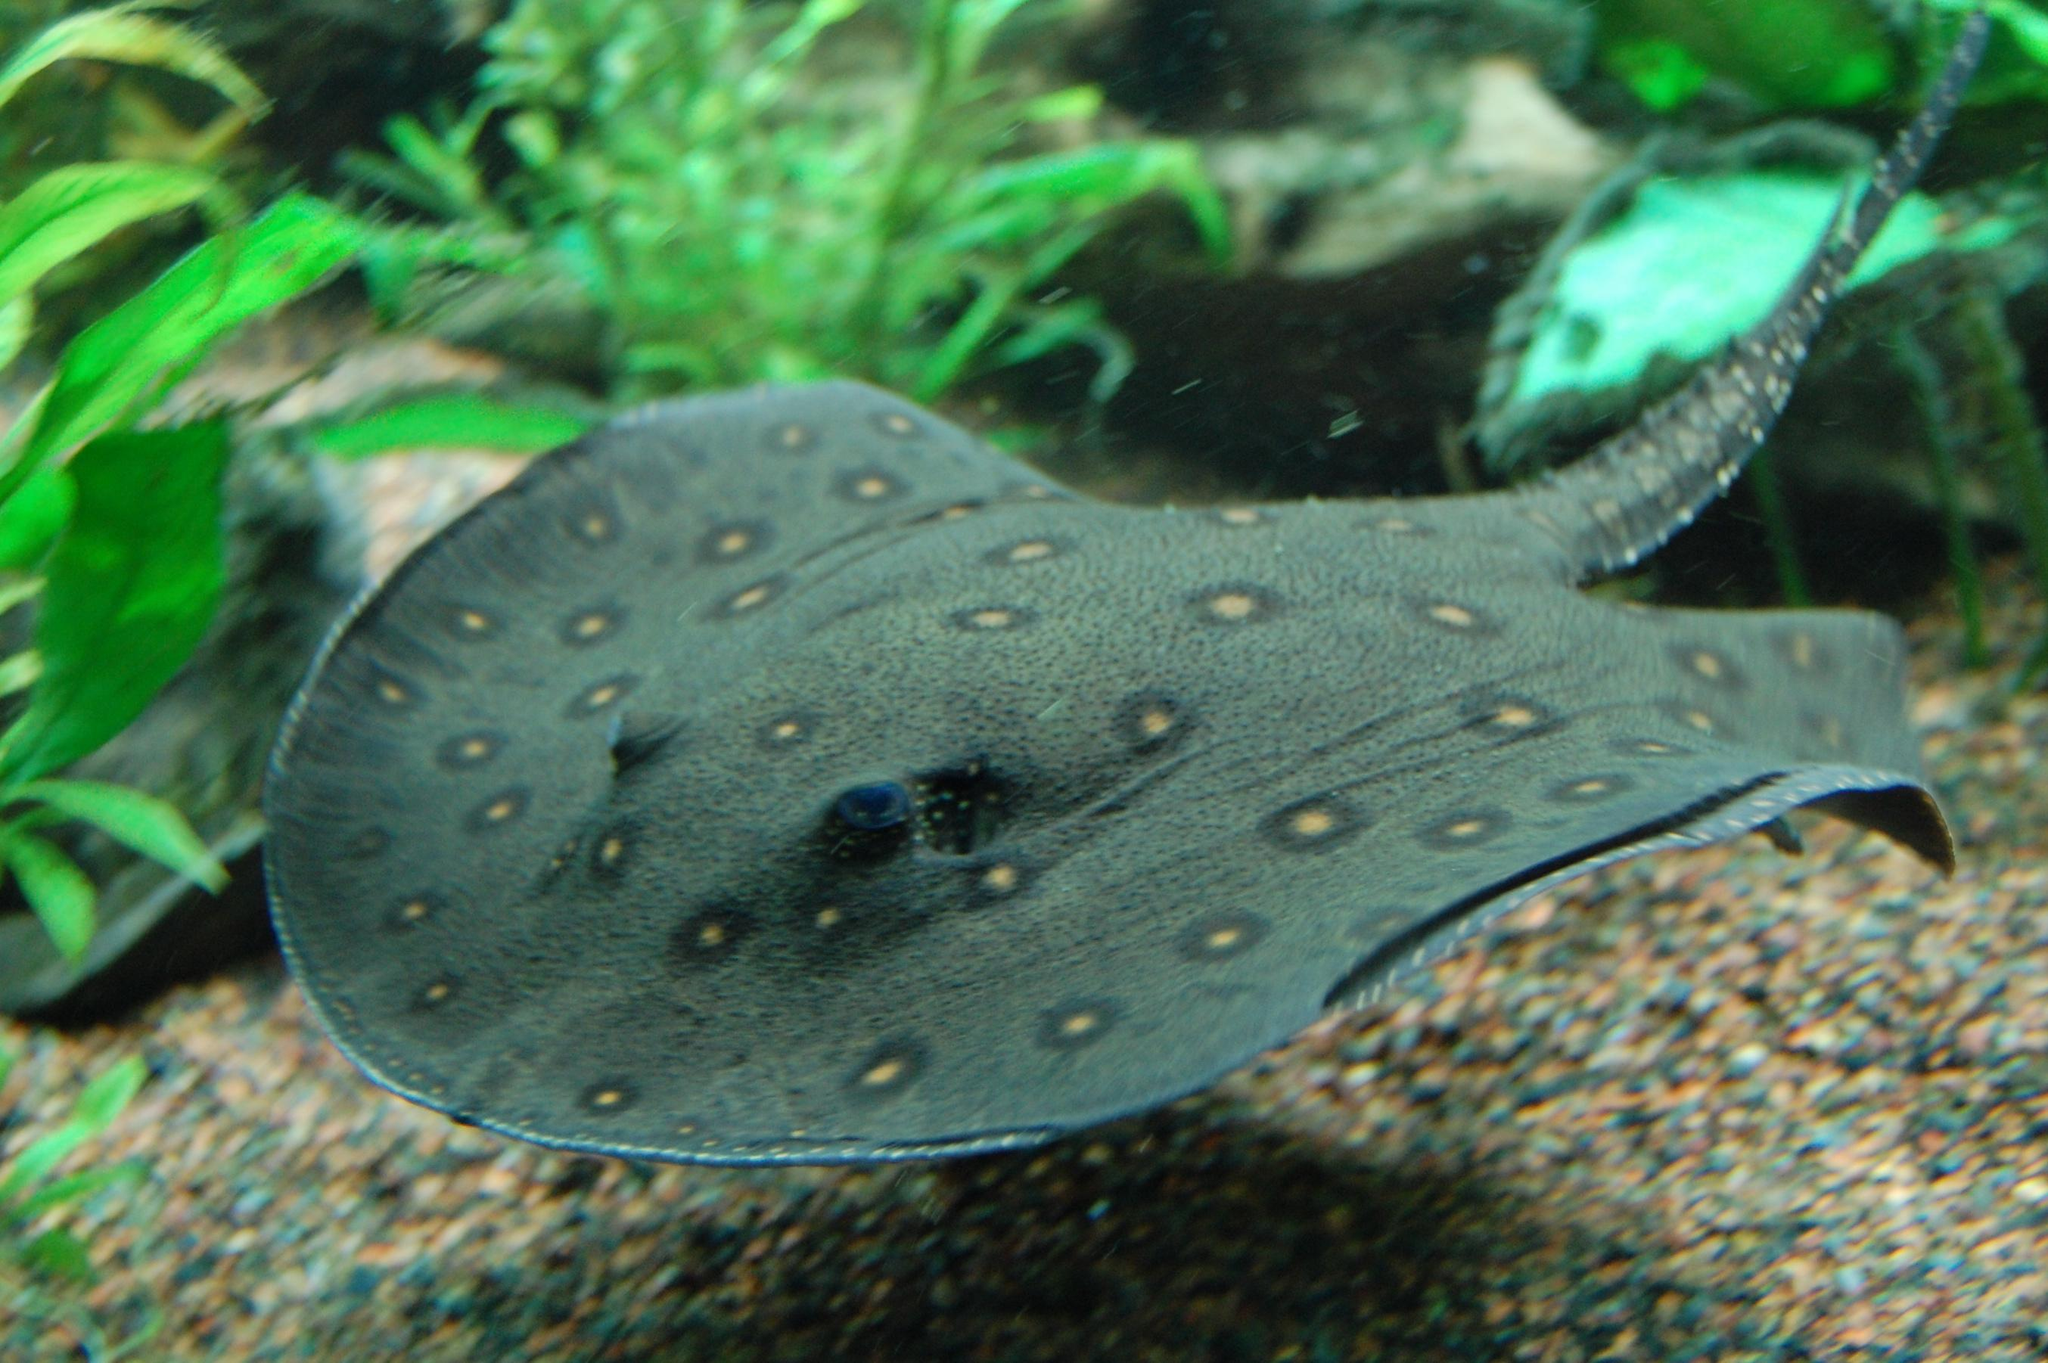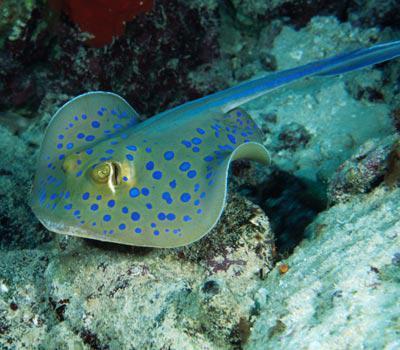The first image is the image on the left, the second image is the image on the right. Assess this claim about the two images: "The creature in the image on the right is pressed flat against the sea floor.". Correct or not? Answer yes or no. No. 